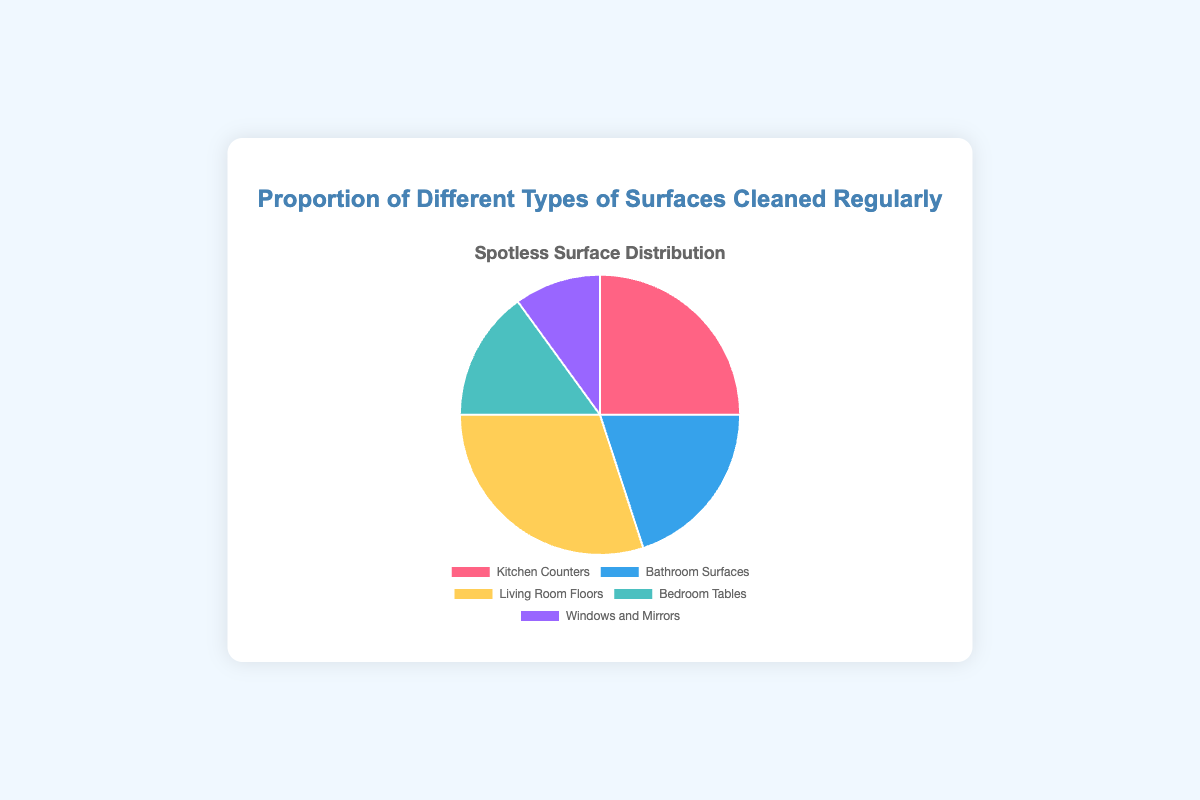What is the most commonly cleaned surface? The pie chart shows the proportion of different types of surfaces. The segment with the largest proportion indicates the most commonly cleaned surface. The "Living Room Floors" segment is the largest at 30%.
Answer: Living Room Floors Which surface is cleaned the least often? Observing the pie chart, the smallest segment represents the least commonly cleaned surface. "Windows and Mirrors" have the smallest proportion at 10%.
Answer: Windows and Mirrors How much more frequently are Living Room Floors cleaned compared to Bedroom Tables? From the pie chart, Living Room Floors are cleaned 30% of the time, and Bedroom Tables are cleaned 15% of the time. The difference is calculated by subtracting the smaller proportion from the larger one: 30% - 15% = 15%.
Answer: 15% What is the combined proportion of Kitchen Counters and Bathroom Surfaces cleaned regularly? According to the pie chart, Kitchen Counters account for 25% and Bathroom Surfaces account for 20%. The combined proportion is calculated by adding the two percentages: 25% + 20% = 45%.
Answer: 45% Which surfaces have proportions that are within 10% of each other? By examining the pie chart, we compare the proportions: Kitchen Counters (25%) and Bathroom Surfaces (20%) differ by 5%, and Bedroom Tables (15%) and Windows and Mirrors (10%) differ by 5%. Both differences are within 10%.
Answer: Kitchen Counters and Bathroom Surfaces; Bedroom Tables and Windows and Mirrors How much less frequently are Windows and Mirrors cleaned compared to Kitchen Counters? From the pie chart, Windows and Mirrors are cleaned 10% of the time, while Kitchen Counters are cleaned 25% of the time. The difference is calculated by subtracting the smaller proportion from the larger one: 25% - 10% = 15%.
Answer: 15% If someone spends exactly double the amount of time cleaning the Living Room Floors as they do the Windows and Mirrors, how much time do they spend cleaning the Living Room Floors? According to the pie chart, Windows and Mirrors are cleaned 10% of the time. Doubling that amount means Living Room Floors would be cleaned 2 * 10% = 20%. However, the chart shows Living Room Floors are cleaned 30%, indicating they spend 10% more time cleaning it than doubled.
Answer: 20% (as they spend 30%, which is 10% more than double) Which surface, apart from Living Room Floors, has the highest cleaning proportion, and what is that proportion? The pie chart shows the proportions of various surfaces. After Living Room Floors (30%), the next highest is Kitchen Counters at 25%.
Answer: Kitchen Counters What proportion of surfaces, other than Windows and Mirrors, is cleaned regularly? By excluding Windows and Mirrors (10%) from the total 100%, the other surfaces would account for 100% - 10% = 90%.
Answer: 90% Out of all the surfaces, which one has a proportion close in value to the total of Bedroom Tables and Windows and Mirrors? The proportions are: Bedroom Tables 15% + Windows and Mirrors 10% = 25%. The closest single surface proportion to 25% is Kitchen Counters at 25%.
Answer: Kitchen Counters 